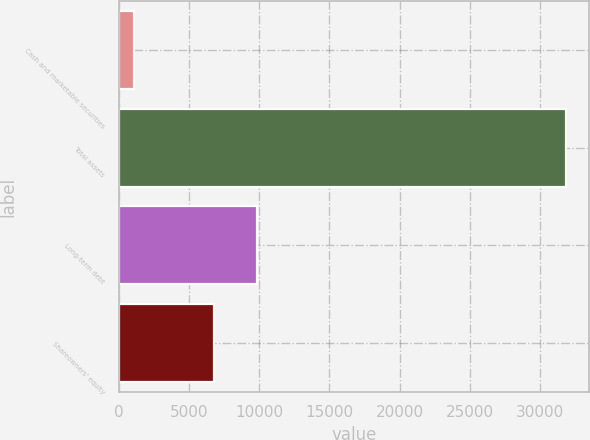Convert chart. <chart><loc_0><loc_0><loc_500><loc_500><bar_chart><fcel>Cash and marketable securities<fcel>Total assets<fcel>Long-term debt<fcel>Shareowners' equity<nl><fcel>1049<fcel>31879<fcel>9863<fcel>6780<nl></chart> 